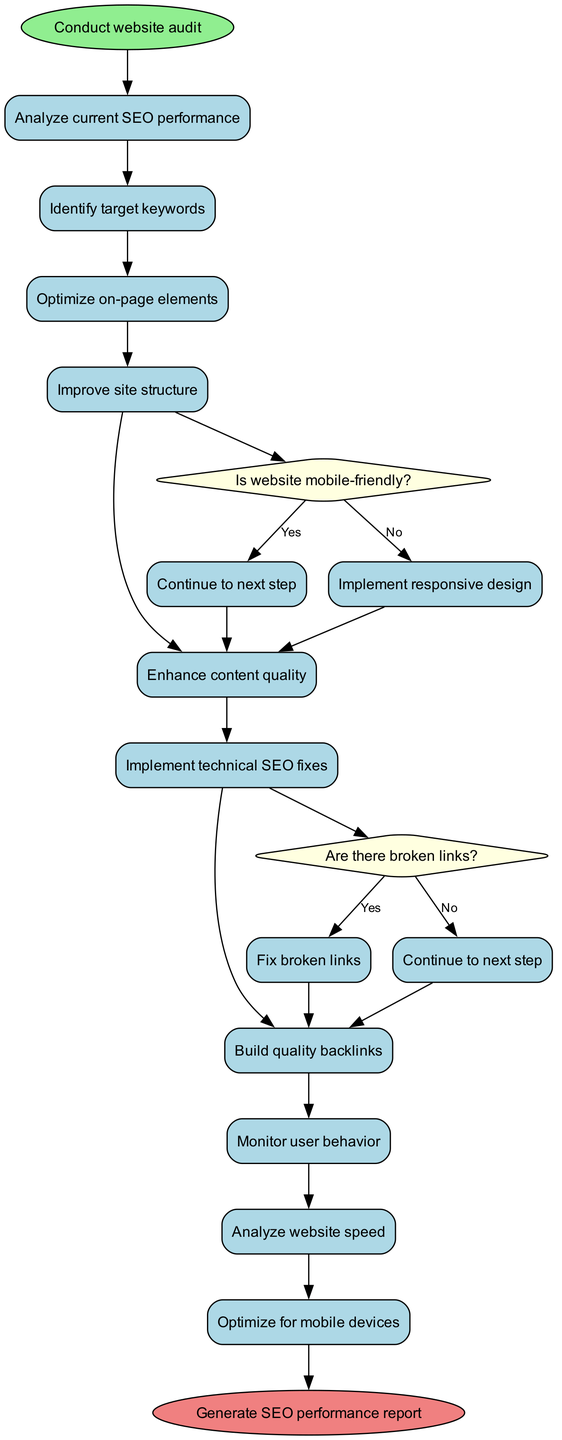What is the first activity in the diagram? The first activity is represented by the arrow leading from the start node to the first activity node, which indicates "Analyze current SEO performance."
Answer: Analyze current SEO performance How many activities are listed in the diagram? By counting the activity nodes from the start to the end, there are 10 activities in total.
Answer: 10 What decision follows optimizing the site structure? The decision node related to optimizing site structure is "Is website mobile-friendly?" and follows after "Improve site structure."
Answer: Is website mobile-friendly? What do you do if the website is not mobile-friendly? According to the flow in the diagram, if the website is not mobile-friendly, the next action is to "Implement responsive design."
Answer: Implement responsive design How many decision nodes are present in the diagram? There are 2 decision nodes displayed in the diagram, each assessing a specific condition related to the activities.
Answer: 2 If the website has broken links, what should be done next? The flow shows that if there are broken links, the next action is to "Fix broken links" after the decision node related to broken links.
Answer: Fix broken links What is the end node of the diagram? The end node is the final action taken in the process, which is "Generate SEO performance report."
Answer: Generate SEO performance report What activity comes after the analysis of website speed? The analysis of website speed leads directly to the next activity, which is "Optimize for mobile devices."
Answer: Optimize for mobile devices What type of diagram is this? The diagram illustrates a process flow specific to analyzing and optimizing a business's website, making it an Activity Diagram.
Answer: Activity Diagram 